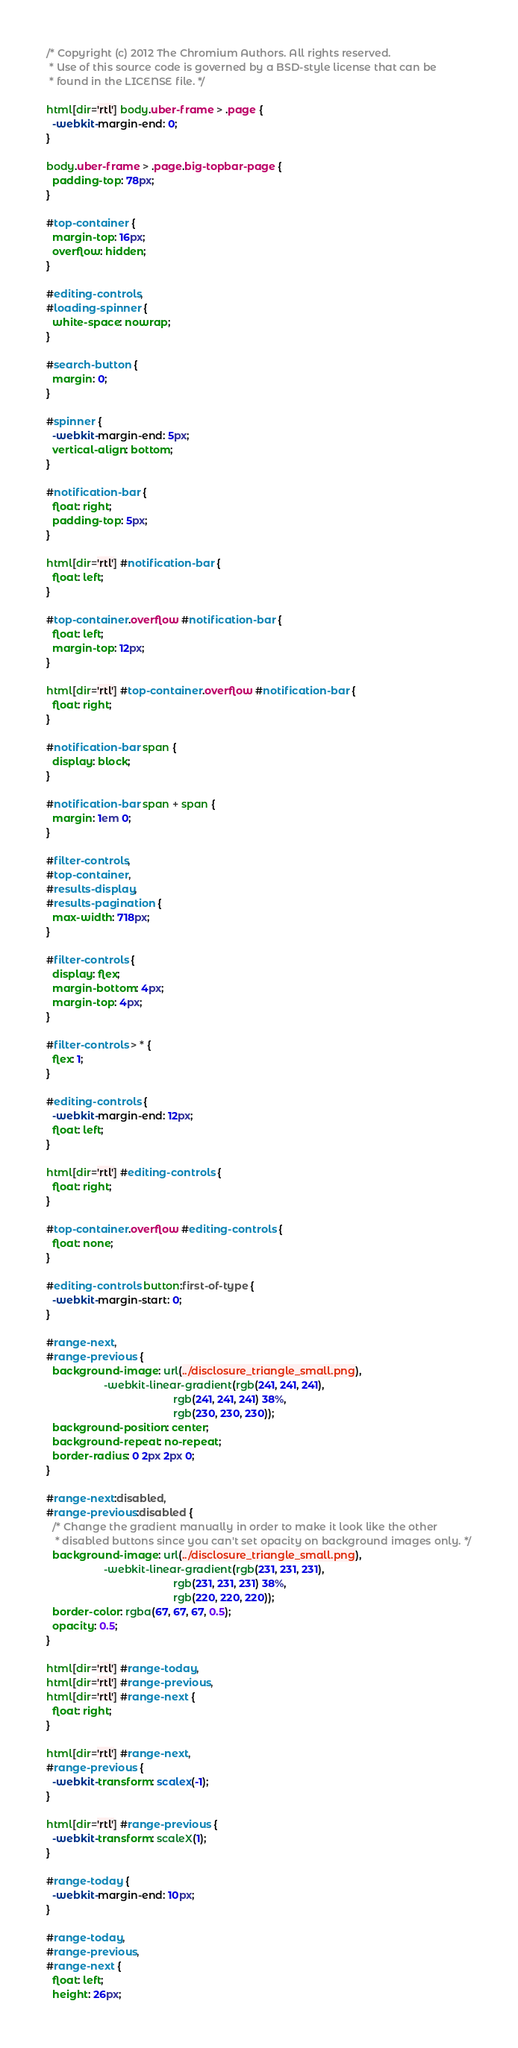<code> <loc_0><loc_0><loc_500><loc_500><_CSS_>/* Copyright (c) 2012 The Chromium Authors. All rights reserved.
 * Use of this source code is governed by a BSD-style license that can be
 * found in the LICENSE file. */

html[dir='rtl'] body.uber-frame > .page {
  -webkit-margin-end: 0;
}

body.uber-frame > .page.big-topbar-page {
  padding-top: 78px;
}

#top-container {
  margin-top: 16px;
  overflow: hidden;
}

#editing-controls,
#loading-spinner {
  white-space: nowrap;
}

#search-button {
  margin: 0;
}

#spinner {
  -webkit-margin-end: 5px;
  vertical-align: bottom;
}

#notification-bar {
  float: right;
  padding-top: 5px;
}

html[dir='rtl'] #notification-bar {
  float: left;
}

#top-container.overflow #notification-bar {
  float: left;
  margin-top: 12px;
}

html[dir='rtl'] #top-container.overflow #notification-bar {
  float: right;
}

#notification-bar span {
  display: block;
}

#notification-bar span + span {
  margin: 1em 0;
}

#filter-controls,
#top-container,
#results-display,
#results-pagination {
  max-width: 718px;
}

#filter-controls {
  display: flex;
  margin-bottom: 4px;
  margin-top: 4px;
}

#filter-controls > * {
  flex: 1;
}

#editing-controls {
  -webkit-margin-end: 12px;
  float: left;
}

html[dir='rtl'] #editing-controls {
  float: right;
}

#top-container.overflow #editing-controls {
  float: none;
}

#editing-controls button:first-of-type {
  -webkit-margin-start: 0;
}

#range-next,
#range-previous {
  background-image: url(../disclosure_triangle_small.png),
                    -webkit-linear-gradient(rgb(241, 241, 241),
                                            rgb(241, 241, 241) 38%,
                                            rgb(230, 230, 230));
  background-position: center;
  background-repeat: no-repeat;
  border-radius: 0 2px 2px 0;
}

#range-next:disabled,
#range-previous:disabled {
  /* Change the gradient manually in order to make it look like the other
   * disabled buttons since you can't set opacity on background images only. */
  background-image: url(../disclosure_triangle_small.png),
                    -webkit-linear-gradient(rgb(231, 231, 231),
                                            rgb(231, 231, 231) 38%,
                                            rgb(220, 220, 220));
  border-color: rgba(67, 67, 67, 0.5);
  opacity: 0.5;
}

html[dir='rtl'] #range-today,
html[dir='rtl'] #range-previous,
html[dir='rtl'] #range-next {
  float: right;
}

html[dir='rtl'] #range-next,
#range-previous {
  -webkit-transform: scalex(-1);
}

html[dir='rtl'] #range-previous {
  -webkit-transform: scaleX(1);
}

#range-today {
  -webkit-margin-end: 10px;
}

#range-today,
#range-previous,
#range-next {
  float: left;
  height: 26px;</code> 